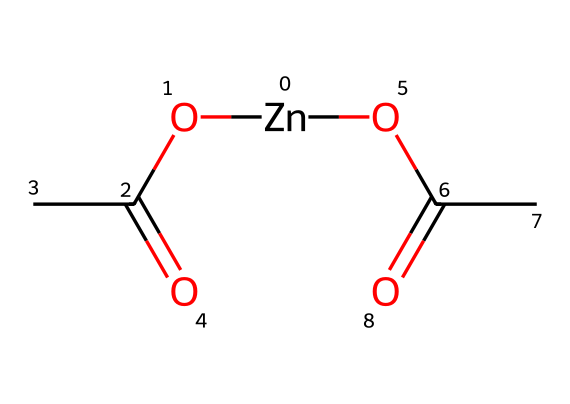How many carbon atoms are present in zinc acetate? The structure contains two acetate groups, each consisting of two carbon atoms. Therefore, there are a total of 2 (from one acetate) + 2 (from the second acetate) = 4 carbon atoms in zinc acetate.
Answer: 4 What is the oxidation state of zinc in this compound? Zinc in compounds typically has an oxidation state of +2. In zinc acetate, zinc is bonded to the negative acetate ions, which confirms the +2 oxidation state.
Answer: +2 How many oxygen atoms are present in the entire structure? Each acetate group has two oxygen atoms, and there are two acetate groups. Therefore, there are 2 (from one acetate) + 2 (from the second acetate) = 4 oxygen atoms, as there are no additional oxygen atoms in the structure.
Answer: 4 What type of compound is zinc acetate classified as? Zinc acetate is classified as a salt because it is formed from the neutralization of acetic acid (a weak acid) and zinc acetate (a metal salt).
Answer: salt What role does zinc acetate play as an electrolyte? Zinc acetate can dissociate in solution to provide zinc ions and acetate ions, allowing it to conduct electricity when dissolved in water. This ability to dissociate into ions makes it useful as an electrolyte.
Answer: conducts electricity What type of reaction is involved in the formation of zinc acetate? The formation of zinc acetate involves acid-base neutralization, where zinc hydroxide or zinc oxide reacts with acetic acid to form zinc acetate and water. This step combines both base and acid to yield a salt.
Answer: acid-base neutralization 